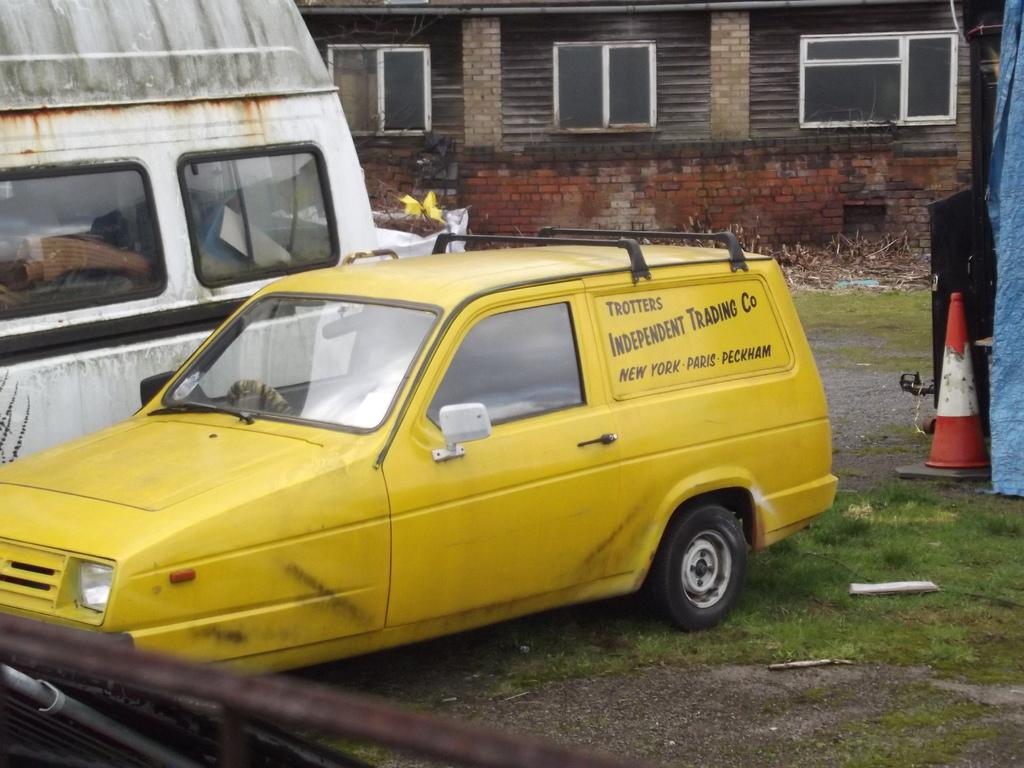<image>
Relay a brief, clear account of the picture shown. A yellow van that says Trotters Independent Trading Company. 